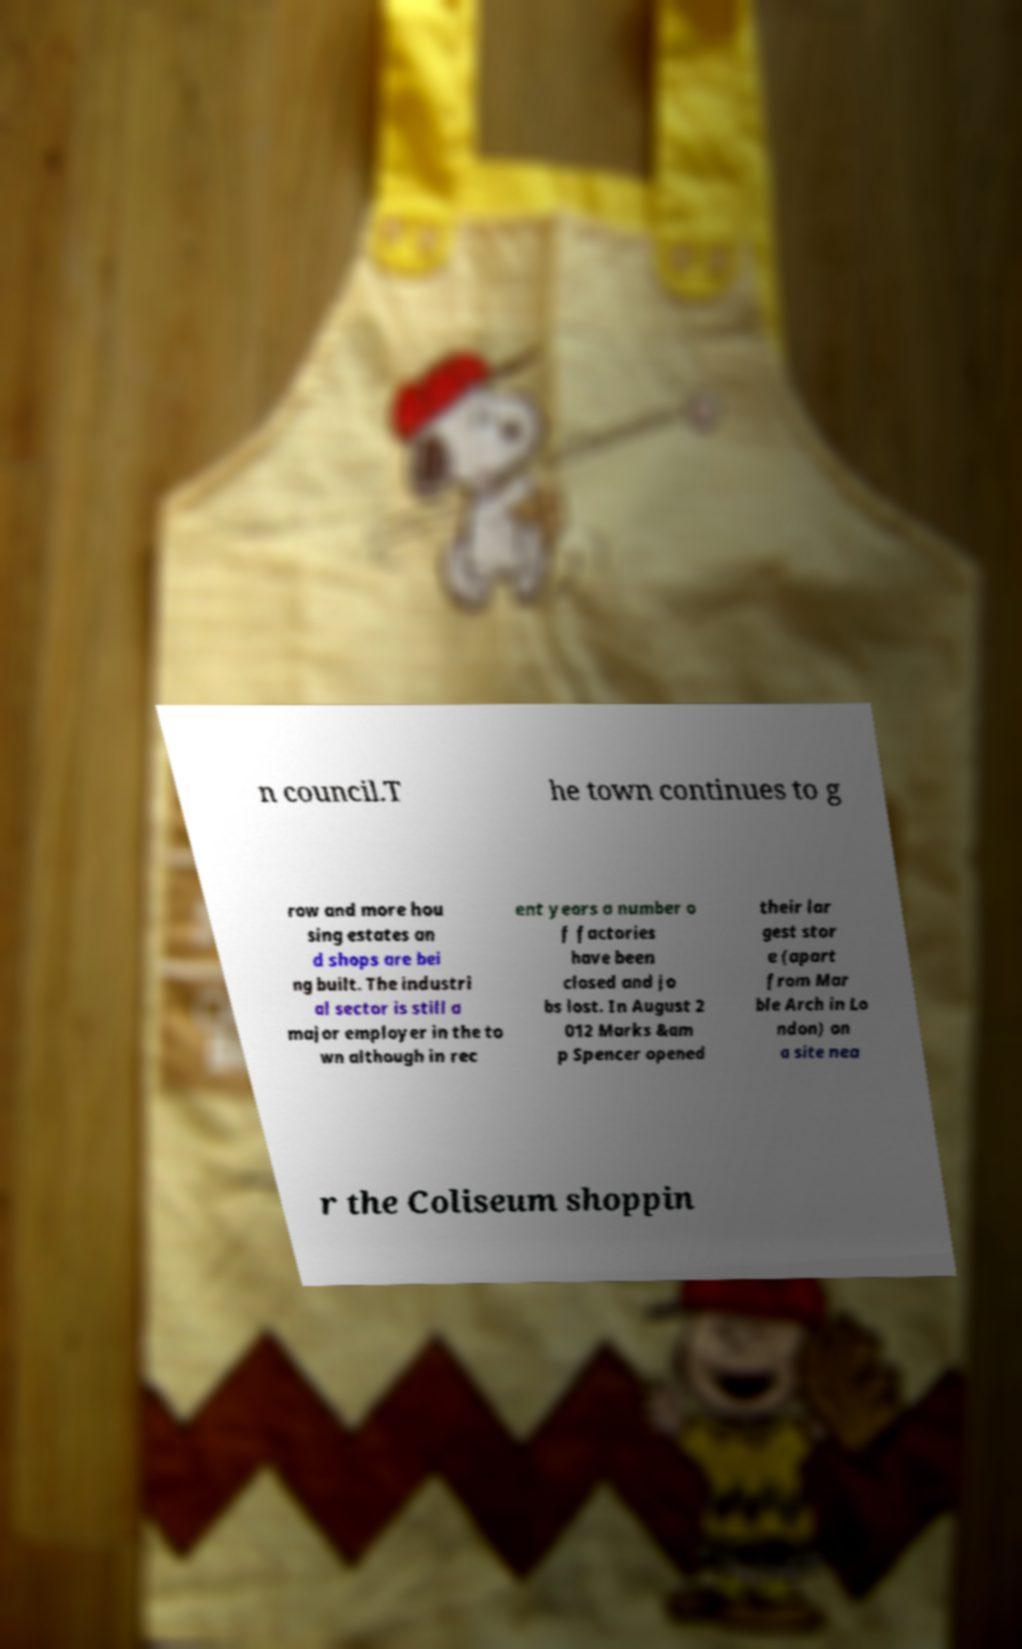Please read and relay the text visible in this image. What does it say? n council.T he town continues to g row and more hou sing estates an d shops are bei ng built. The industri al sector is still a major employer in the to wn although in rec ent years a number o f factories have been closed and jo bs lost. In August 2 012 Marks &am p Spencer opened their lar gest stor e (apart from Mar ble Arch in Lo ndon) on a site nea r the Coliseum shoppin 